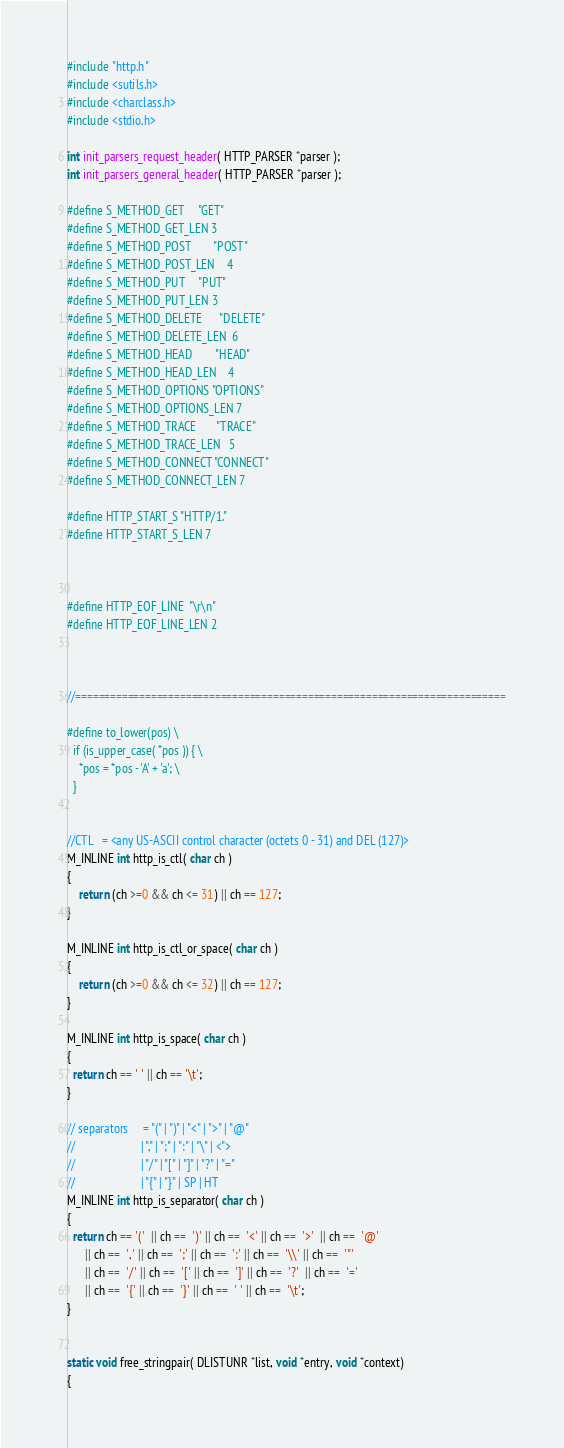Convert code to text. <code><loc_0><loc_0><loc_500><loc_500><_C_>#include "http.h"
#include <sutils.h> 
#include <charclass.h>
#include <stdio.h>

int init_parsers_request_header( HTTP_PARSER *parser );
int init_parsers_general_header( HTTP_PARSER *parser );
 
#define S_METHOD_GET		"GET"
#define S_METHOD_GET_LEN	3
#define S_METHOD_POST		"POST" 
#define S_METHOD_POST_LEN	4
#define S_METHOD_PUT		"PUT"
#define S_METHOD_PUT_LEN	3
#define S_METHOD_DELETE		"DELETE"
#define S_METHOD_DELETE_LEN	6
#define S_METHOD_HEAD		"HEAD"
#define S_METHOD_HEAD_LEN	4
#define S_METHOD_OPTIONS	"OPTIONS"
#define S_METHOD_OPTIONS_LEN	7
#define S_METHOD_TRACE		"TRACE"
#define S_METHOD_TRACE_LEN	5
#define S_METHOD_CONNECT	"CONNECT"
#define S_METHOD_CONNECT_LEN	7

#define HTTP_START_S "HTTP/1."
#define HTTP_START_S_LEN 7



#define HTTP_EOF_LINE  "\r\n"
#define HTTP_EOF_LINE_LEN 2



//==========================================================================

#define to_lower(pos) \
  if (is_upper_case( *pos )) { \
    *pos = *pos - 'A' + 'a'; \
  }


//CTL   = <any US-ASCII control character (octets 0 - 31) and DEL (127)>
M_INLINE int http_is_ctl( char ch )
{
    return (ch >=0 && ch <= 31) || ch == 127;
}

M_INLINE int http_is_ctl_or_space( char ch )
{
    return (ch >=0 && ch <= 32) || ch == 127;
}

M_INLINE int http_is_space( char ch )
{
  return ch == ' ' || ch == '\t';
}

// separators     = "(" | ")" | "<" | ">" | "@"
//                      | "," | ";" | ":" | "\" | <">
//                      | "/" | "[" | "]" | "?" | "="
//                      | "{" | "}" | SP | HT
M_INLINE int http_is_separator( char ch )
{
  return ch == '('  || ch ==  ')' || ch ==  '<' || ch ==  '>'  || ch ==  '@'
      || ch ==  ',' || ch ==  ';' || ch ==  ':' || ch ==  '\\' || ch ==  '"'
      || ch ==  '/' || ch ==  '[' || ch ==  ']' || ch ==  '?'  || ch ==  '='
      || ch ==  '{' || ch ==  '}' || ch ==  ' ' || ch ==  '\t';
}


static void free_stringpair( DLISTUNR *list, void *entry, void *context)
{</code> 